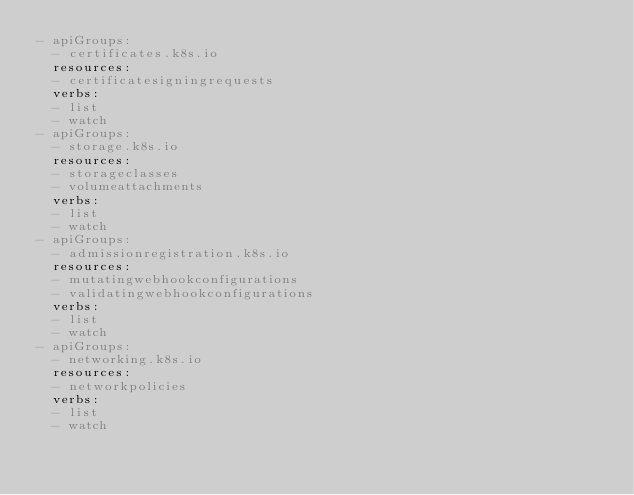Convert code to text. <code><loc_0><loc_0><loc_500><loc_500><_YAML_>- apiGroups:
  - certificates.k8s.io
  resources:
  - certificatesigningrequests
  verbs:
  - list
  - watch
- apiGroups:
  - storage.k8s.io
  resources:
  - storageclasses
  - volumeattachments
  verbs:
  - list
  - watch
- apiGroups:
  - admissionregistration.k8s.io
  resources:
  - mutatingwebhookconfigurations
  - validatingwebhookconfigurations
  verbs:
  - list
  - watch
- apiGroups:
  - networking.k8s.io
  resources:
  - networkpolicies
  verbs:
  - list
  - watch
</code> 